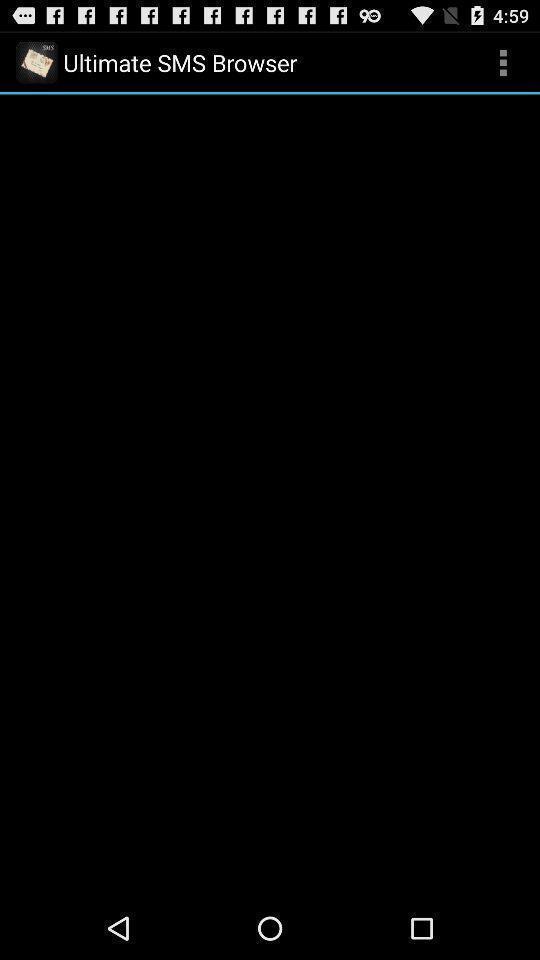Explain the elements present in this screenshot. One of the page of sms browser app. 